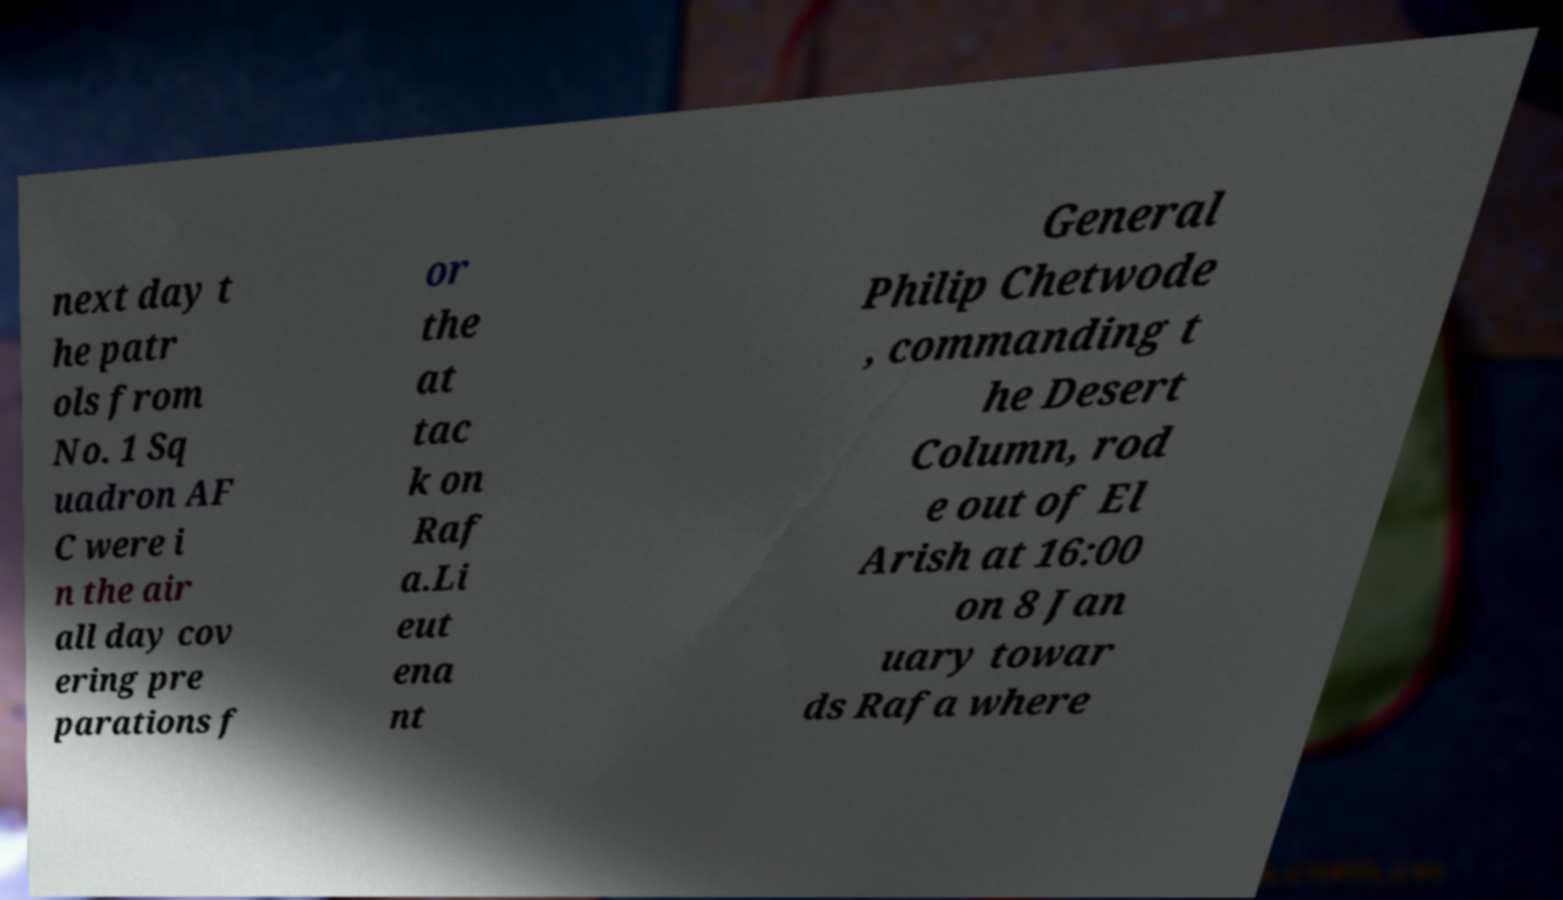Could you extract and type out the text from this image? next day t he patr ols from No. 1 Sq uadron AF C were i n the air all day cov ering pre parations f or the at tac k on Raf a.Li eut ena nt General Philip Chetwode , commanding t he Desert Column, rod e out of El Arish at 16:00 on 8 Jan uary towar ds Rafa where 